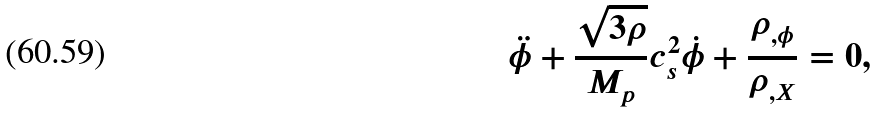Convert formula to latex. <formula><loc_0><loc_0><loc_500><loc_500>\ddot { \phi } + \frac { \sqrt { 3 \rho } } { M _ { p } } c _ { s } ^ { 2 } \dot { \phi } + \frac { \rho _ { , \phi } } { \rho _ { , X } } = 0 ,</formula> 